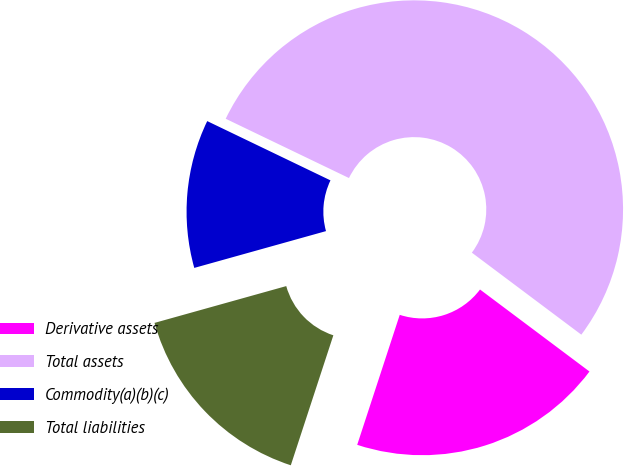<chart> <loc_0><loc_0><loc_500><loc_500><pie_chart><fcel>Derivative assets<fcel>Total assets<fcel>Commodity(a)(b)(c)<fcel>Total liabilities<nl><fcel>19.8%<fcel>53.1%<fcel>11.47%<fcel>15.63%<nl></chart> 